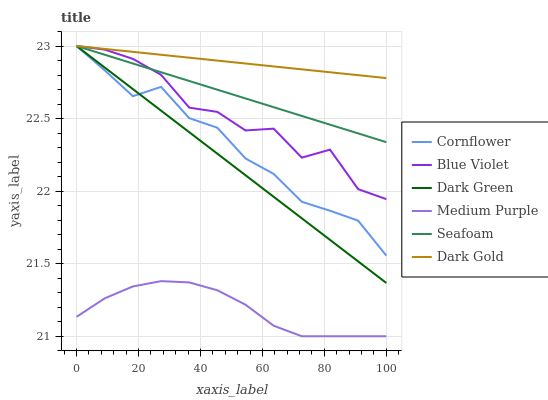Does Medium Purple have the minimum area under the curve?
Answer yes or no. Yes. Does Dark Gold have the maximum area under the curve?
Answer yes or no. Yes. Does Seafoam have the minimum area under the curve?
Answer yes or no. No. Does Seafoam have the maximum area under the curve?
Answer yes or no. No. Is Dark Green the smoothest?
Answer yes or no. Yes. Is Blue Violet the roughest?
Answer yes or no. Yes. Is Dark Gold the smoothest?
Answer yes or no. No. Is Dark Gold the roughest?
Answer yes or no. No. Does Medium Purple have the lowest value?
Answer yes or no. Yes. Does Seafoam have the lowest value?
Answer yes or no. No. Does Dark Green have the highest value?
Answer yes or no. Yes. Does Medium Purple have the highest value?
Answer yes or no. No. Is Medium Purple less than Dark Green?
Answer yes or no. Yes. Is Cornflower greater than Medium Purple?
Answer yes or no. Yes. Does Seafoam intersect Dark Gold?
Answer yes or no. Yes. Is Seafoam less than Dark Gold?
Answer yes or no. No. Is Seafoam greater than Dark Gold?
Answer yes or no. No. Does Medium Purple intersect Dark Green?
Answer yes or no. No. 